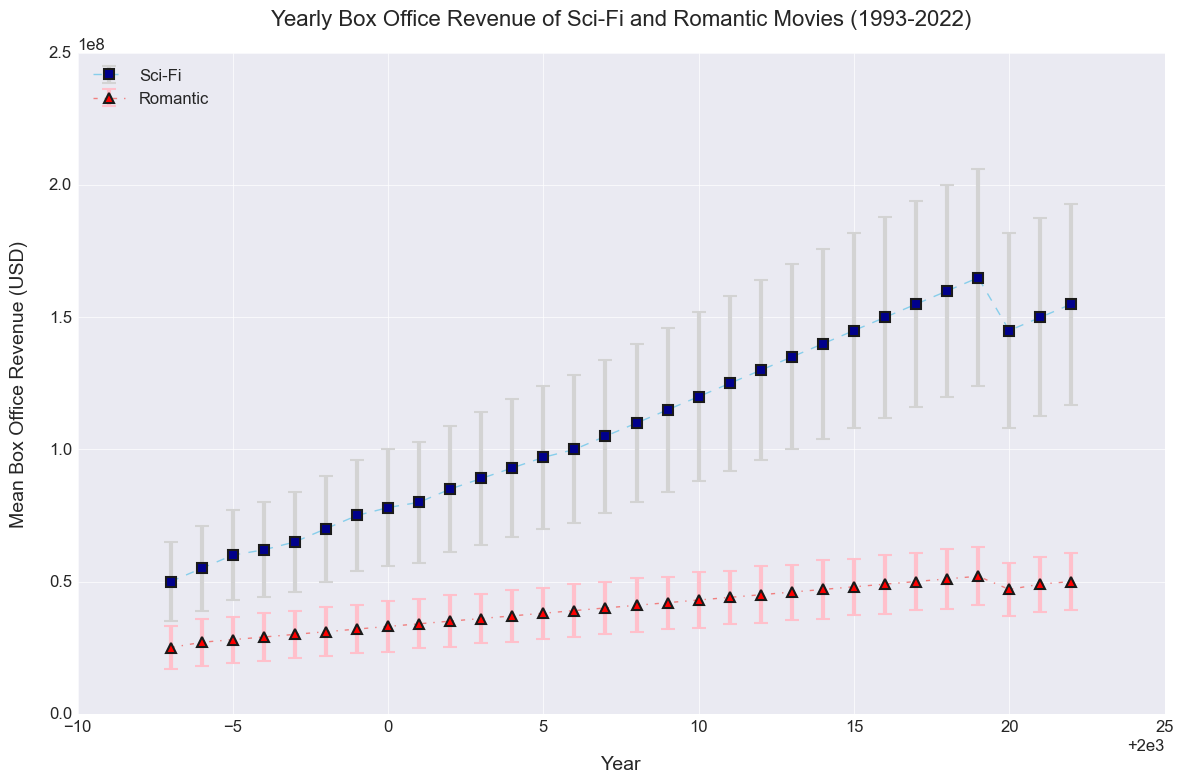Which genre had the highest mean box office revenue in 2022? Look at the end of the time period in 2022. Check the mean box office revenue for both genres. Sci-Fi has the highest value.
Answer: Sci-Fi What is the trend in the mean box office revenue for Sci-Fi movies from 1993 to 2019? Observe the plotted points and the line connecting them for Sci-Fi movies from 1993 to 2019. The trend shows a gradual increase in box office revenue.
Answer: Increasing Which year had the smallest difference between the mean box office revenues of the two genres? Calculate the difference between the mean box office revenues of Sci-Fi and Romantic movies for each year. The year with the smallest difference is 2011.
Answer: 2011 In which year did Romantic movies have the highest mean box office revenue? Look for the highest point on the Romantic movies plot. The highest value appears in 2019.
Answer: 2019 Explain how the variability in box office revenues for Sci-Fi movies compares to Romantic movies over the years. Compare the error bars for both Sci-Fi and Romantic genres. Larger error bars indicate higher variability. Sci-Fi movies generally have larger error bars, showing more variability.
Answer: Sci-Fi has more variability What was the approximate mean box office revenue for Sci-Fi movies in 2010? Find the point on the Sci-Fi plot corresponding to the year 2010. The value is about 120 million USD.
Answer: 120 million USD How did the box office revenue for Romantic movies change between 2020 and 2022? Observe the plotted points for Romantic movies between 2020 and 2022. The revenue increased from 47 million USD to 50 million USD.
Answer: Increased What can you infer about the box office revenue for Sci-Fi movies in 2020 compared to 2019? Compare the plotted points for Sci-Fi movies in 2019 and 2020. The revenue decreased from 165 million USD in 2019 to 145 million USD in 2020.
Answer: Decreased Which genre showed more consistent growth in the mean box office revenue over the period shown? Compare the overall trends and error bars for both genres. Romantic movies show a more consistent growth trend with smaller fluctuations.
Answer: Romantic 